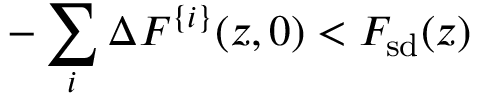<formula> <loc_0><loc_0><loc_500><loc_500>- \sum _ { i } \Delta F ^ { \{ i \} } ( z , 0 ) < F _ { s d } ( z )</formula> 